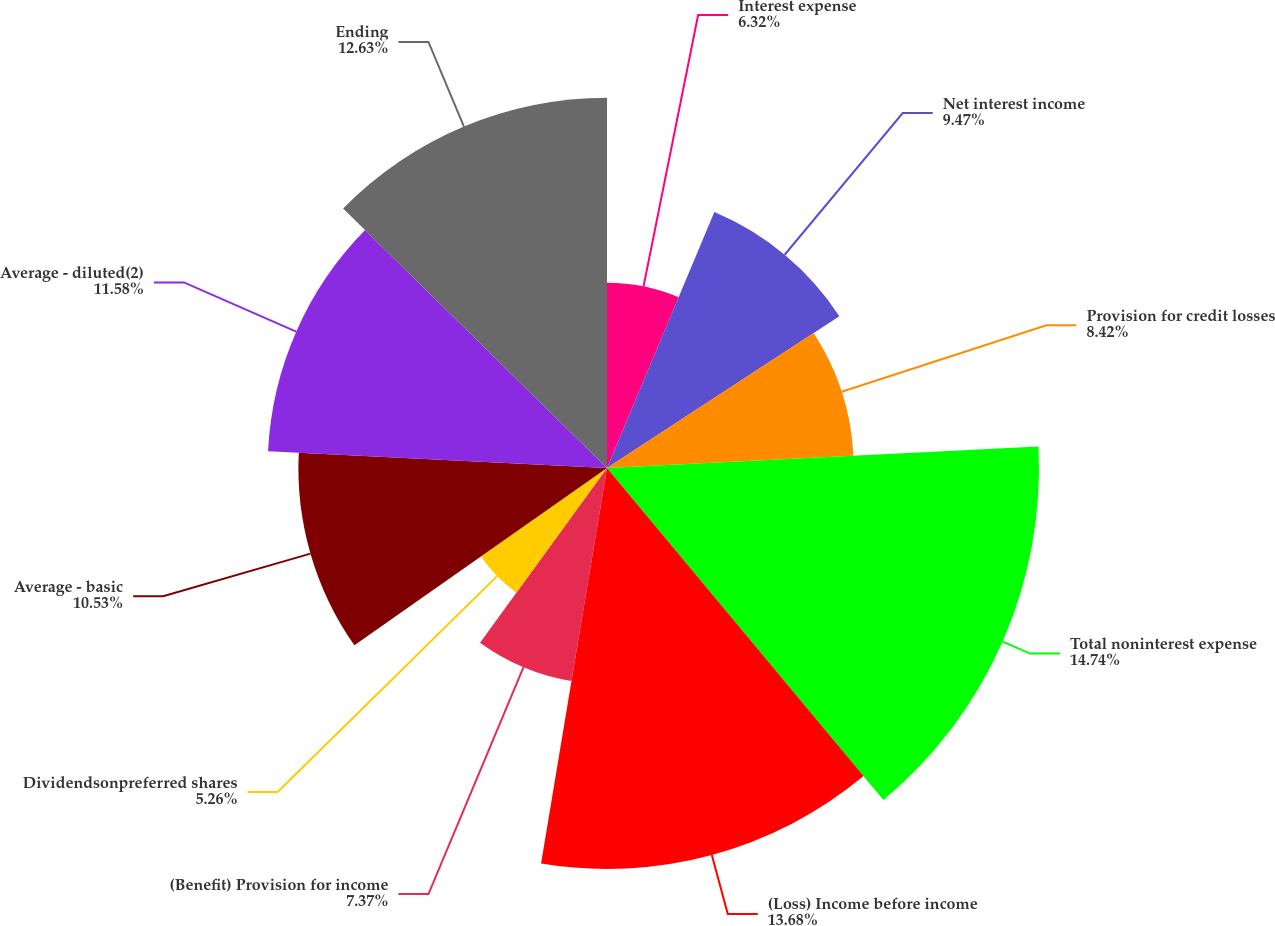Convert chart to OTSL. <chart><loc_0><loc_0><loc_500><loc_500><pie_chart><fcel>Interest expense<fcel>Net interest income<fcel>Provision for credit losses<fcel>Total noninterest expense<fcel>(Loss) Income before income<fcel>(Benefit) Provision for income<fcel>Dividendsonpreferred shares<fcel>Average - basic<fcel>Average - diluted(2)<fcel>Ending<nl><fcel>6.32%<fcel>9.47%<fcel>8.42%<fcel>14.74%<fcel>13.68%<fcel>7.37%<fcel>5.26%<fcel>10.53%<fcel>11.58%<fcel>12.63%<nl></chart> 